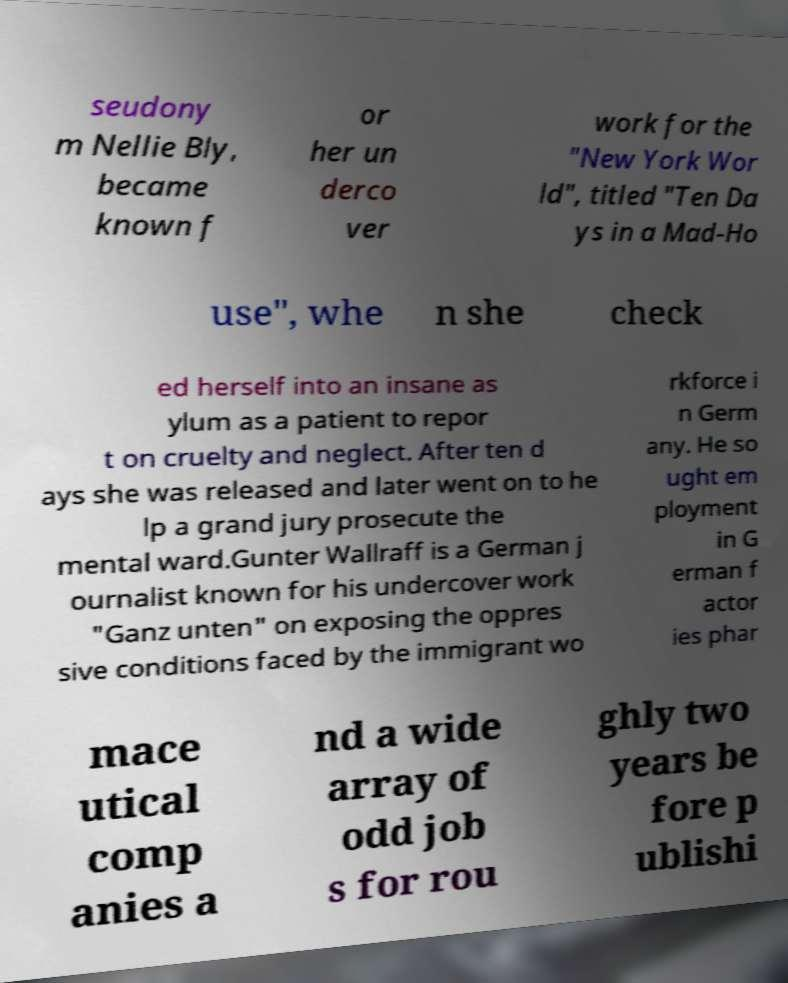I need the written content from this picture converted into text. Can you do that? seudony m Nellie Bly, became known f or her un derco ver work for the "New York Wor ld", titled "Ten Da ys in a Mad-Ho use", whe n she check ed herself into an insane as ylum as a patient to repor t on cruelty and neglect. After ten d ays she was released and later went on to he lp a grand jury prosecute the mental ward.Gunter Wallraff is a German j ournalist known for his undercover work "Ganz unten" on exposing the oppres sive conditions faced by the immigrant wo rkforce i n Germ any. He so ught em ployment in G erman f actor ies phar mace utical comp anies a nd a wide array of odd job s for rou ghly two years be fore p ublishi 